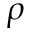<formula> <loc_0><loc_0><loc_500><loc_500>\rho</formula> 